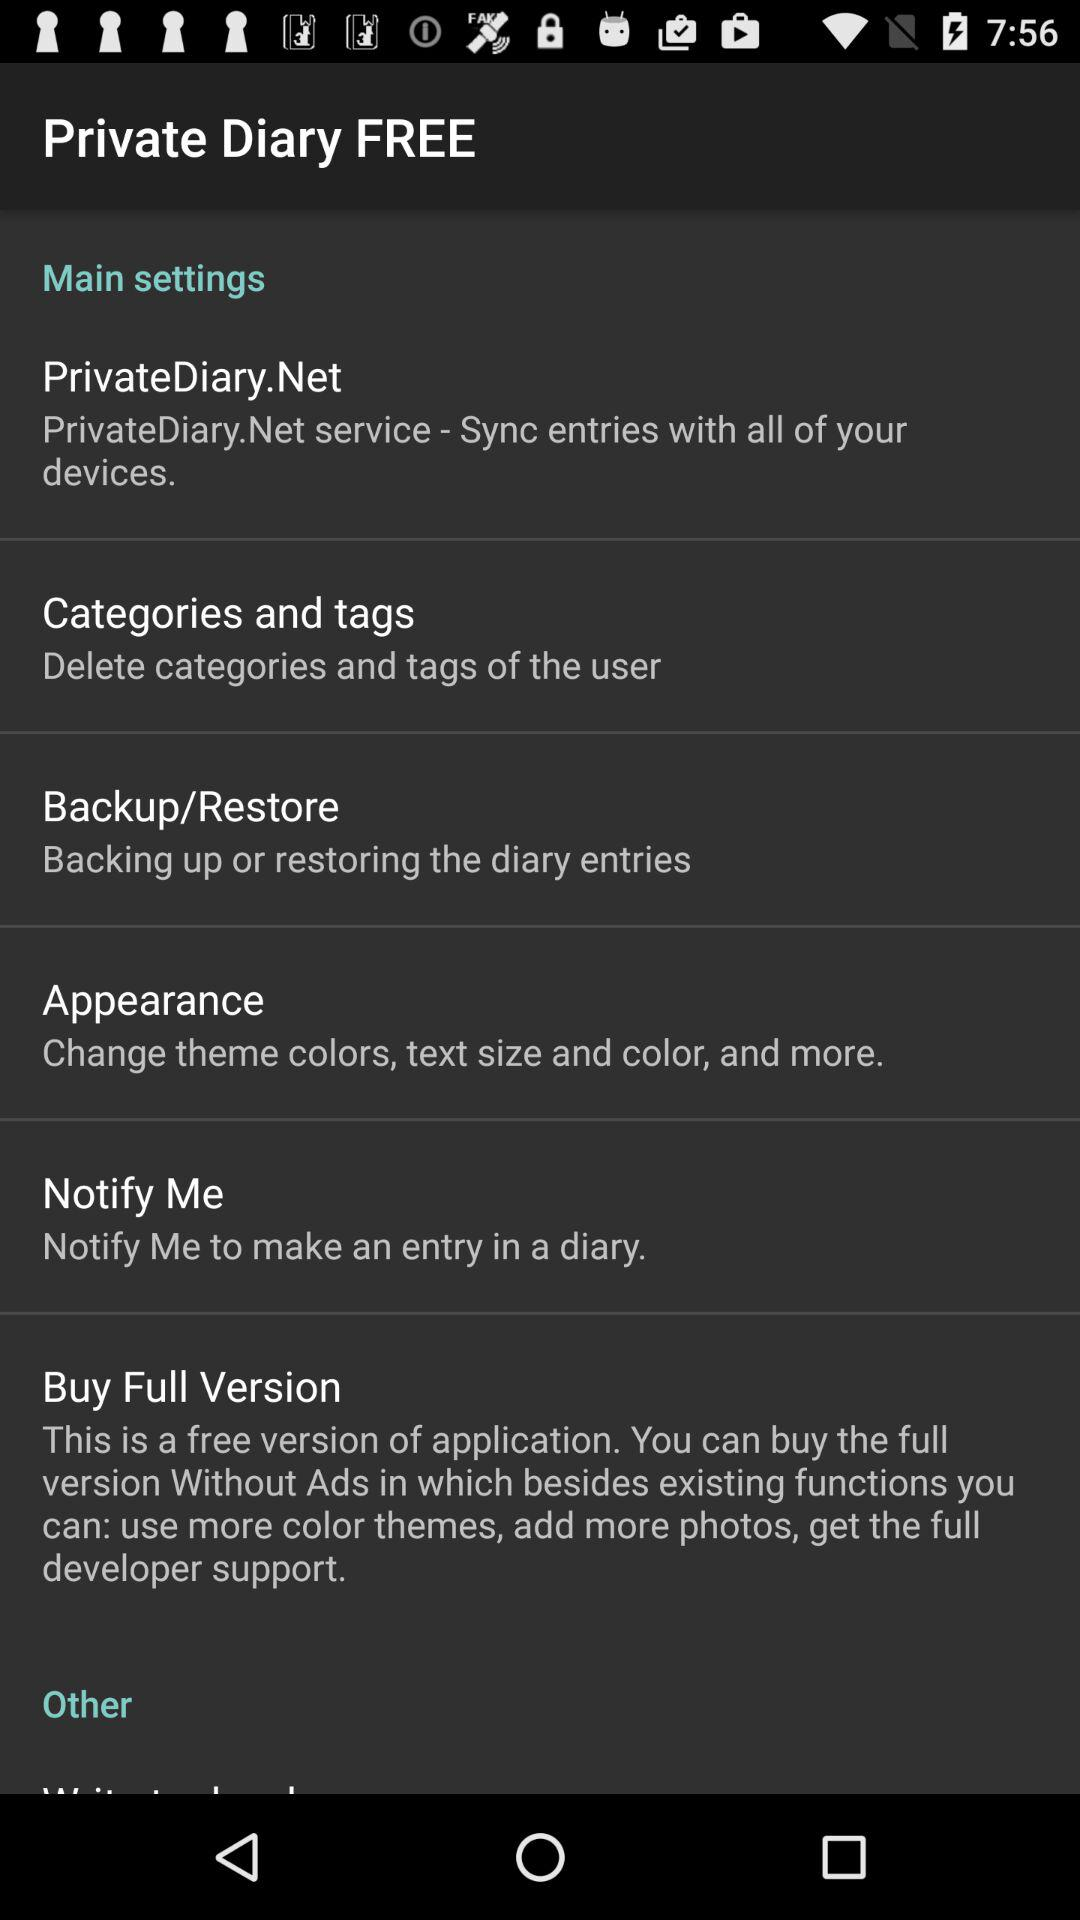What is the description of "Notify Me"? The description of "Notify Me" is "Notify Me to make an entry in a diary". 